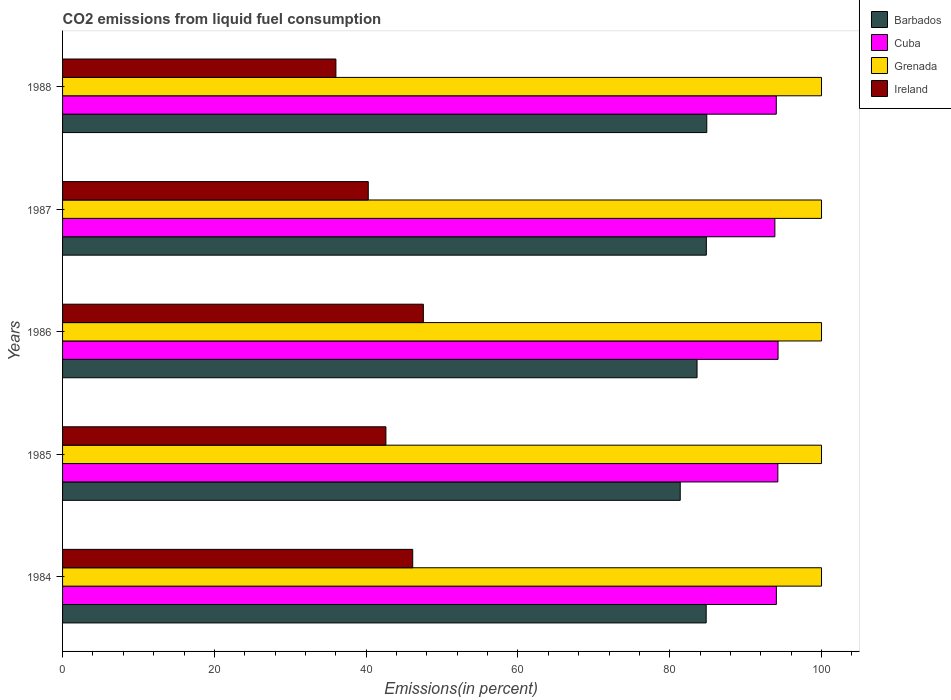How many groups of bars are there?
Offer a very short reply. 5. Are the number of bars per tick equal to the number of legend labels?
Provide a short and direct response. Yes. Are the number of bars on each tick of the Y-axis equal?
Offer a terse response. Yes. How many bars are there on the 4th tick from the top?
Offer a very short reply. 4. How many bars are there on the 4th tick from the bottom?
Offer a terse response. 4. What is the label of the 1st group of bars from the top?
Ensure brevity in your answer.  1988. In how many cases, is the number of bars for a given year not equal to the number of legend labels?
Give a very brief answer. 0. What is the total CO2 emitted in Cuba in 1985?
Provide a short and direct response. 94.25. Across all years, what is the maximum total CO2 emitted in Grenada?
Offer a terse response. 100. Across all years, what is the minimum total CO2 emitted in Grenada?
Your response must be concise. 100. In which year was the total CO2 emitted in Cuba minimum?
Your response must be concise. 1987. What is the total total CO2 emitted in Ireland in the graph?
Provide a short and direct response. 212.57. What is the difference between the total CO2 emitted in Cuba in 1984 and that in 1987?
Your answer should be very brief. 0.2. What is the difference between the total CO2 emitted in Cuba in 1985 and the total CO2 emitted in Ireland in 1986?
Keep it short and to the point. 46.71. What is the average total CO2 emitted in Barbados per year?
Make the answer very short. 83.9. In the year 1988, what is the difference between the total CO2 emitted in Barbados and total CO2 emitted in Ireland?
Your response must be concise. 48.87. What is the ratio of the total CO2 emitted in Barbados in 1986 to that in 1988?
Give a very brief answer. 0.98. Is the total CO2 emitted in Grenada in 1984 less than that in 1988?
Ensure brevity in your answer.  No. What is the difference between the highest and the second highest total CO2 emitted in Ireland?
Your response must be concise. 1.4. What is the difference between the highest and the lowest total CO2 emitted in Grenada?
Make the answer very short. 0. In how many years, is the total CO2 emitted in Grenada greater than the average total CO2 emitted in Grenada taken over all years?
Offer a very short reply. 0. What does the 3rd bar from the top in 1984 represents?
Keep it short and to the point. Cuba. What does the 2nd bar from the bottom in 1985 represents?
Your answer should be compact. Cuba. Is it the case that in every year, the sum of the total CO2 emitted in Grenada and total CO2 emitted in Cuba is greater than the total CO2 emitted in Ireland?
Offer a terse response. Yes. How many bars are there?
Offer a terse response. 20. Are all the bars in the graph horizontal?
Offer a terse response. Yes. How many years are there in the graph?
Make the answer very short. 5. What is the difference between two consecutive major ticks on the X-axis?
Your answer should be very brief. 20. Does the graph contain any zero values?
Ensure brevity in your answer.  No. Does the graph contain grids?
Give a very brief answer. No. Where does the legend appear in the graph?
Keep it short and to the point. Top right. What is the title of the graph?
Your response must be concise. CO2 emissions from liquid fuel consumption. Does "Caribbean small states" appear as one of the legend labels in the graph?
Provide a succinct answer. No. What is the label or title of the X-axis?
Provide a succinct answer. Emissions(in percent). What is the label or title of the Y-axis?
Make the answer very short. Years. What is the Emissions(in percent) of Barbados in 1984?
Your answer should be very brief. 84.8. What is the Emissions(in percent) of Cuba in 1984?
Keep it short and to the point. 94.05. What is the Emissions(in percent) in Ireland in 1984?
Provide a short and direct response. 46.14. What is the Emissions(in percent) of Barbados in 1985?
Provide a short and direct response. 81.39. What is the Emissions(in percent) of Cuba in 1985?
Keep it short and to the point. 94.25. What is the Emissions(in percent) of Grenada in 1985?
Provide a succinct answer. 100. What is the Emissions(in percent) in Ireland in 1985?
Keep it short and to the point. 42.6. What is the Emissions(in percent) of Barbados in 1986?
Make the answer very short. 83.6. What is the Emissions(in percent) in Cuba in 1986?
Keep it short and to the point. 94.28. What is the Emissions(in percent) in Ireland in 1986?
Give a very brief answer. 47.54. What is the Emissions(in percent) in Barbados in 1987?
Ensure brevity in your answer.  84.82. What is the Emissions(in percent) of Cuba in 1987?
Make the answer very short. 93.85. What is the Emissions(in percent) in Ireland in 1987?
Your answer should be compact. 40.28. What is the Emissions(in percent) in Barbados in 1988?
Keep it short and to the point. 84.88. What is the Emissions(in percent) of Cuba in 1988?
Provide a succinct answer. 94.04. What is the Emissions(in percent) in Ireland in 1988?
Offer a very short reply. 36.02. Across all years, what is the maximum Emissions(in percent) in Barbados?
Your response must be concise. 84.88. Across all years, what is the maximum Emissions(in percent) in Cuba?
Your response must be concise. 94.28. Across all years, what is the maximum Emissions(in percent) of Grenada?
Provide a succinct answer. 100. Across all years, what is the maximum Emissions(in percent) in Ireland?
Give a very brief answer. 47.54. Across all years, what is the minimum Emissions(in percent) in Barbados?
Offer a terse response. 81.39. Across all years, what is the minimum Emissions(in percent) in Cuba?
Provide a short and direct response. 93.85. Across all years, what is the minimum Emissions(in percent) in Ireland?
Provide a short and direct response. 36.02. What is the total Emissions(in percent) in Barbados in the graph?
Provide a succinct answer. 419.5. What is the total Emissions(in percent) in Cuba in the graph?
Your response must be concise. 470.47. What is the total Emissions(in percent) in Grenada in the graph?
Provide a succinct answer. 500. What is the total Emissions(in percent) of Ireland in the graph?
Your answer should be very brief. 212.57. What is the difference between the Emissions(in percent) in Barbados in 1984 and that in 1985?
Provide a short and direct response. 3.42. What is the difference between the Emissions(in percent) of Cuba in 1984 and that in 1985?
Your response must be concise. -0.2. What is the difference between the Emissions(in percent) in Ireland in 1984 and that in 1985?
Your response must be concise. 3.53. What is the difference between the Emissions(in percent) in Barbados in 1984 and that in 1986?
Provide a succinct answer. 1.2. What is the difference between the Emissions(in percent) in Cuba in 1984 and that in 1986?
Offer a very short reply. -0.23. What is the difference between the Emissions(in percent) in Grenada in 1984 and that in 1986?
Keep it short and to the point. 0. What is the difference between the Emissions(in percent) in Ireland in 1984 and that in 1986?
Your response must be concise. -1.4. What is the difference between the Emissions(in percent) in Barbados in 1984 and that in 1987?
Your answer should be compact. -0.02. What is the difference between the Emissions(in percent) in Cuba in 1984 and that in 1987?
Your answer should be compact. 0.2. What is the difference between the Emissions(in percent) of Grenada in 1984 and that in 1987?
Offer a terse response. 0. What is the difference between the Emissions(in percent) in Ireland in 1984 and that in 1987?
Keep it short and to the point. 5.86. What is the difference between the Emissions(in percent) in Barbados in 1984 and that in 1988?
Your answer should be compact. -0.08. What is the difference between the Emissions(in percent) of Cuba in 1984 and that in 1988?
Your answer should be compact. 0.01. What is the difference between the Emissions(in percent) of Grenada in 1984 and that in 1988?
Provide a succinct answer. 0. What is the difference between the Emissions(in percent) of Ireland in 1984 and that in 1988?
Make the answer very short. 10.12. What is the difference between the Emissions(in percent) of Barbados in 1985 and that in 1986?
Offer a very short reply. -2.21. What is the difference between the Emissions(in percent) of Cuba in 1985 and that in 1986?
Offer a terse response. -0.03. What is the difference between the Emissions(in percent) in Grenada in 1985 and that in 1986?
Keep it short and to the point. 0. What is the difference between the Emissions(in percent) of Ireland in 1985 and that in 1986?
Your response must be concise. -4.93. What is the difference between the Emissions(in percent) in Barbados in 1985 and that in 1987?
Ensure brevity in your answer.  -3.44. What is the difference between the Emissions(in percent) in Cuba in 1985 and that in 1987?
Keep it short and to the point. 0.39. What is the difference between the Emissions(in percent) of Grenada in 1985 and that in 1987?
Ensure brevity in your answer.  0. What is the difference between the Emissions(in percent) of Ireland in 1985 and that in 1987?
Your answer should be very brief. 2.33. What is the difference between the Emissions(in percent) of Barbados in 1985 and that in 1988?
Your response must be concise. -3.5. What is the difference between the Emissions(in percent) of Cuba in 1985 and that in 1988?
Give a very brief answer. 0.21. What is the difference between the Emissions(in percent) in Ireland in 1985 and that in 1988?
Your answer should be compact. 6.59. What is the difference between the Emissions(in percent) in Barbados in 1986 and that in 1987?
Your answer should be very brief. -1.22. What is the difference between the Emissions(in percent) of Cuba in 1986 and that in 1987?
Ensure brevity in your answer.  0.42. What is the difference between the Emissions(in percent) of Ireland in 1986 and that in 1987?
Your response must be concise. 7.26. What is the difference between the Emissions(in percent) in Barbados in 1986 and that in 1988?
Keep it short and to the point. -1.28. What is the difference between the Emissions(in percent) in Cuba in 1986 and that in 1988?
Offer a very short reply. 0.23. What is the difference between the Emissions(in percent) of Grenada in 1986 and that in 1988?
Offer a terse response. 0. What is the difference between the Emissions(in percent) in Ireland in 1986 and that in 1988?
Your answer should be compact. 11.52. What is the difference between the Emissions(in percent) of Barbados in 1987 and that in 1988?
Your response must be concise. -0.06. What is the difference between the Emissions(in percent) in Cuba in 1987 and that in 1988?
Provide a short and direct response. -0.19. What is the difference between the Emissions(in percent) in Grenada in 1987 and that in 1988?
Offer a very short reply. 0. What is the difference between the Emissions(in percent) in Ireland in 1987 and that in 1988?
Your answer should be very brief. 4.26. What is the difference between the Emissions(in percent) in Barbados in 1984 and the Emissions(in percent) in Cuba in 1985?
Provide a succinct answer. -9.44. What is the difference between the Emissions(in percent) in Barbados in 1984 and the Emissions(in percent) in Grenada in 1985?
Provide a succinct answer. -15.2. What is the difference between the Emissions(in percent) of Barbados in 1984 and the Emissions(in percent) of Ireland in 1985?
Give a very brief answer. 42.2. What is the difference between the Emissions(in percent) in Cuba in 1984 and the Emissions(in percent) in Grenada in 1985?
Keep it short and to the point. -5.95. What is the difference between the Emissions(in percent) in Cuba in 1984 and the Emissions(in percent) in Ireland in 1985?
Provide a short and direct response. 51.45. What is the difference between the Emissions(in percent) of Grenada in 1984 and the Emissions(in percent) of Ireland in 1985?
Provide a short and direct response. 57.4. What is the difference between the Emissions(in percent) in Barbados in 1984 and the Emissions(in percent) in Cuba in 1986?
Give a very brief answer. -9.47. What is the difference between the Emissions(in percent) in Barbados in 1984 and the Emissions(in percent) in Grenada in 1986?
Your answer should be very brief. -15.2. What is the difference between the Emissions(in percent) of Barbados in 1984 and the Emissions(in percent) of Ireland in 1986?
Offer a very short reply. 37.27. What is the difference between the Emissions(in percent) of Cuba in 1984 and the Emissions(in percent) of Grenada in 1986?
Your answer should be very brief. -5.95. What is the difference between the Emissions(in percent) of Cuba in 1984 and the Emissions(in percent) of Ireland in 1986?
Give a very brief answer. 46.51. What is the difference between the Emissions(in percent) of Grenada in 1984 and the Emissions(in percent) of Ireland in 1986?
Provide a short and direct response. 52.46. What is the difference between the Emissions(in percent) in Barbados in 1984 and the Emissions(in percent) in Cuba in 1987?
Your answer should be compact. -9.05. What is the difference between the Emissions(in percent) in Barbados in 1984 and the Emissions(in percent) in Grenada in 1987?
Provide a short and direct response. -15.2. What is the difference between the Emissions(in percent) in Barbados in 1984 and the Emissions(in percent) in Ireland in 1987?
Provide a short and direct response. 44.52. What is the difference between the Emissions(in percent) in Cuba in 1984 and the Emissions(in percent) in Grenada in 1987?
Your answer should be very brief. -5.95. What is the difference between the Emissions(in percent) of Cuba in 1984 and the Emissions(in percent) of Ireland in 1987?
Provide a succinct answer. 53.77. What is the difference between the Emissions(in percent) of Grenada in 1984 and the Emissions(in percent) of Ireland in 1987?
Provide a short and direct response. 59.72. What is the difference between the Emissions(in percent) of Barbados in 1984 and the Emissions(in percent) of Cuba in 1988?
Offer a terse response. -9.24. What is the difference between the Emissions(in percent) in Barbados in 1984 and the Emissions(in percent) in Grenada in 1988?
Provide a succinct answer. -15.2. What is the difference between the Emissions(in percent) of Barbados in 1984 and the Emissions(in percent) of Ireland in 1988?
Offer a very short reply. 48.79. What is the difference between the Emissions(in percent) of Cuba in 1984 and the Emissions(in percent) of Grenada in 1988?
Provide a short and direct response. -5.95. What is the difference between the Emissions(in percent) in Cuba in 1984 and the Emissions(in percent) in Ireland in 1988?
Offer a terse response. 58.03. What is the difference between the Emissions(in percent) of Grenada in 1984 and the Emissions(in percent) of Ireland in 1988?
Your answer should be compact. 63.98. What is the difference between the Emissions(in percent) in Barbados in 1985 and the Emissions(in percent) in Cuba in 1986?
Your response must be concise. -12.89. What is the difference between the Emissions(in percent) of Barbados in 1985 and the Emissions(in percent) of Grenada in 1986?
Ensure brevity in your answer.  -18.61. What is the difference between the Emissions(in percent) in Barbados in 1985 and the Emissions(in percent) in Ireland in 1986?
Provide a succinct answer. 33.85. What is the difference between the Emissions(in percent) in Cuba in 1985 and the Emissions(in percent) in Grenada in 1986?
Offer a very short reply. -5.75. What is the difference between the Emissions(in percent) of Cuba in 1985 and the Emissions(in percent) of Ireland in 1986?
Your answer should be compact. 46.71. What is the difference between the Emissions(in percent) in Grenada in 1985 and the Emissions(in percent) in Ireland in 1986?
Offer a terse response. 52.46. What is the difference between the Emissions(in percent) in Barbados in 1985 and the Emissions(in percent) in Cuba in 1987?
Your answer should be compact. -12.47. What is the difference between the Emissions(in percent) of Barbados in 1985 and the Emissions(in percent) of Grenada in 1987?
Provide a short and direct response. -18.61. What is the difference between the Emissions(in percent) in Barbados in 1985 and the Emissions(in percent) in Ireland in 1987?
Ensure brevity in your answer.  41.11. What is the difference between the Emissions(in percent) in Cuba in 1985 and the Emissions(in percent) in Grenada in 1987?
Ensure brevity in your answer.  -5.75. What is the difference between the Emissions(in percent) of Cuba in 1985 and the Emissions(in percent) of Ireland in 1987?
Your response must be concise. 53.97. What is the difference between the Emissions(in percent) in Grenada in 1985 and the Emissions(in percent) in Ireland in 1987?
Keep it short and to the point. 59.72. What is the difference between the Emissions(in percent) in Barbados in 1985 and the Emissions(in percent) in Cuba in 1988?
Give a very brief answer. -12.66. What is the difference between the Emissions(in percent) in Barbados in 1985 and the Emissions(in percent) in Grenada in 1988?
Offer a terse response. -18.61. What is the difference between the Emissions(in percent) of Barbados in 1985 and the Emissions(in percent) of Ireland in 1988?
Keep it short and to the point. 45.37. What is the difference between the Emissions(in percent) of Cuba in 1985 and the Emissions(in percent) of Grenada in 1988?
Offer a very short reply. -5.75. What is the difference between the Emissions(in percent) of Cuba in 1985 and the Emissions(in percent) of Ireland in 1988?
Keep it short and to the point. 58.23. What is the difference between the Emissions(in percent) of Grenada in 1985 and the Emissions(in percent) of Ireland in 1988?
Offer a terse response. 63.98. What is the difference between the Emissions(in percent) of Barbados in 1986 and the Emissions(in percent) of Cuba in 1987?
Your response must be concise. -10.25. What is the difference between the Emissions(in percent) in Barbados in 1986 and the Emissions(in percent) in Grenada in 1987?
Your answer should be compact. -16.4. What is the difference between the Emissions(in percent) in Barbados in 1986 and the Emissions(in percent) in Ireland in 1987?
Give a very brief answer. 43.32. What is the difference between the Emissions(in percent) in Cuba in 1986 and the Emissions(in percent) in Grenada in 1987?
Your answer should be very brief. -5.72. What is the difference between the Emissions(in percent) in Cuba in 1986 and the Emissions(in percent) in Ireland in 1987?
Your answer should be compact. 54. What is the difference between the Emissions(in percent) of Grenada in 1986 and the Emissions(in percent) of Ireland in 1987?
Make the answer very short. 59.72. What is the difference between the Emissions(in percent) in Barbados in 1986 and the Emissions(in percent) in Cuba in 1988?
Your response must be concise. -10.44. What is the difference between the Emissions(in percent) of Barbados in 1986 and the Emissions(in percent) of Grenada in 1988?
Offer a terse response. -16.4. What is the difference between the Emissions(in percent) of Barbados in 1986 and the Emissions(in percent) of Ireland in 1988?
Ensure brevity in your answer.  47.58. What is the difference between the Emissions(in percent) in Cuba in 1986 and the Emissions(in percent) in Grenada in 1988?
Provide a short and direct response. -5.72. What is the difference between the Emissions(in percent) in Cuba in 1986 and the Emissions(in percent) in Ireland in 1988?
Your response must be concise. 58.26. What is the difference between the Emissions(in percent) in Grenada in 1986 and the Emissions(in percent) in Ireland in 1988?
Ensure brevity in your answer.  63.98. What is the difference between the Emissions(in percent) in Barbados in 1987 and the Emissions(in percent) in Cuba in 1988?
Your response must be concise. -9.22. What is the difference between the Emissions(in percent) in Barbados in 1987 and the Emissions(in percent) in Grenada in 1988?
Offer a terse response. -15.18. What is the difference between the Emissions(in percent) in Barbados in 1987 and the Emissions(in percent) in Ireland in 1988?
Your response must be concise. 48.81. What is the difference between the Emissions(in percent) of Cuba in 1987 and the Emissions(in percent) of Grenada in 1988?
Give a very brief answer. -6.15. What is the difference between the Emissions(in percent) of Cuba in 1987 and the Emissions(in percent) of Ireland in 1988?
Your answer should be very brief. 57.84. What is the difference between the Emissions(in percent) of Grenada in 1987 and the Emissions(in percent) of Ireland in 1988?
Your answer should be compact. 63.98. What is the average Emissions(in percent) of Barbados per year?
Offer a very short reply. 83.9. What is the average Emissions(in percent) in Cuba per year?
Make the answer very short. 94.09. What is the average Emissions(in percent) of Ireland per year?
Your answer should be very brief. 42.51. In the year 1984, what is the difference between the Emissions(in percent) of Barbados and Emissions(in percent) of Cuba?
Your response must be concise. -9.25. In the year 1984, what is the difference between the Emissions(in percent) of Barbados and Emissions(in percent) of Grenada?
Your response must be concise. -15.2. In the year 1984, what is the difference between the Emissions(in percent) of Barbados and Emissions(in percent) of Ireland?
Ensure brevity in your answer.  38.67. In the year 1984, what is the difference between the Emissions(in percent) in Cuba and Emissions(in percent) in Grenada?
Provide a short and direct response. -5.95. In the year 1984, what is the difference between the Emissions(in percent) of Cuba and Emissions(in percent) of Ireland?
Keep it short and to the point. 47.91. In the year 1984, what is the difference between the Emissions(in percent) in Grenada and Emissions(in percent) in Ireland?
Your response must be concise. 53.86. In the year 1985, what is the difference between the Emissions(in percent) of Barbados and Emissions(in percent) of Cuba?
Your answer should be very brief. -12.86. In the year 1985, what is the difference between the Emissions(in percent) in Barbados and Emissions(in percent) in Grenada?
Make the answer very short. -18.61. In the year 1985, what is the difference between the Emissions(in percent) in Barbados and Emissions(in percent) in Ireland?
Make the answer very short. 38.78. In the year 1985, what is the difference between the Emissions(in percent) in Cuba and Emissions(in percent) in Grenada?
Make the answer very short. -5.75. In the year 1985, what is the difference between the Emissions(in percent) of Cuba and Emissions(in percent) of Ireland?
Offer a very short reply. 51.64. In the year 1985, what is the difference between the Emissions(in percent) in Grenada and Emissions(in percent) in Ireland?
Make the answer very short. 57.4. In the year 1986, what is the difference between the Emissions(in percent) of Barbados and Emissions(in percent) of Cuba?
Provide a succinct answer. -10.68. In the year 1986, what is the difference between the Emissions(in percent) in Barbados and Emissions(in percent) in Grenada?
Give a very brief answer. -16.4. In the year 1986, what is the difference between the Emissions(in percent) of Barbados and Emissions(in percent) of Ireland?
Offer a terse response. 36.06. In the year 1986, what is the difference between the Emissions(in percent) of Cuba and Emissions(in percent) of Grenada?
Make the answer very short. -5.72. In the year 1986, what is the difference between the Emissions(in percent) of Cuba and Emissions(in percent) of Ireland?
Keep it short and to the point. 46.74. In the year 1986, what is the difference between the Emissions(in percent) in Grenada and Emissions(in percent) in Ireland?
Offer a terse response. 52.46. In the year 1987, what is the difference between the Emissions(in percent) of Barbados and Emissions(in percent) of Cuba?
Make the answer very short. -9.03. In the year 1987, what is the difference between the Emissions(in percent) of Barbados and Emissions(in percent) of Grenada?
Your answer should be compact. -15.18. In the year 1987, what is the difference between the Emissions(in percent) in Barbados and Emissions(in percent) in Ireland?
Ensure brevity in your answer.  44.55. In the year 1987, what is the difference between the Emissions(in percent) of Cuba and Emissions(in percent) of Grenada?
Offer a very short reply. -6.15. In the year 1987, what is the difference between the Emissions(in percent) in Cuba and Emissions(in percent) in Ireland?
Your answer should be very brief. 53.58. In the year 1987, what is the difference between the Emissions(in percent) of Grenada and Emissions(in percent) of Ireland?
Provide a succinct answer. 59.72. In the year 1988, what is the difference between the Emissions(in percent) of Barbados and Emissions(in percent) of Cuba?
Ensure brevity in your answer.  -9.16. In the year 1988, what is the difference between the Emissions(in percent) in Barbados and Emissions(in percent) in Grenada?
Keep it short and to the point. -15.12. In the year 1988, what is the difference between the Emissions(in percent) of Barbados and Emissions(in percent) of Ireland?
Your response must be concise. 48.87. In the year 1988, what is the difference between the Emissions(in percent) in Cuba and Emissions(in percent) in Grenada?
Your answer should be compact. -5.96. In the year 1988, what is the difference between the Emissions(in percent) of Cuba and Emissions(in percent) of Ireland?
Your response must be concise. 58.03. In the year 1988, what is the difference between the Emissions(in percent) in Grenada and Emissions(in percent) in Ireland?
Ensure brevity in your answer.  63.98. What is the ratio of the Emissions(in percent) in Barbados in 1984 to that in 1985?
Your answer should be compact. 1.04. What is the ratio of the Emissions(in percent) in Grenada in 1984 to that in 1985?
Keep it short and to the point. 1. What is the ratio of the Emissions(in percent) of Ireland in 1984 to that in 1985?
Your answer should be very brief. 1.08. What is the ratio of the Emissions(in percent) of Barbados in 1984 to that in 1986?
Give a very brief answer. 1.01. What is the ratio of the Emissions(in percent) of Ireland in 1984 to that in 1986?
Provide a succinct answer. 0.97. What is the ratio of the Emissions(in percent) of Barbados in 1984 to that in 1987?
Provide a succinct answer. 1. What is the ratio of the Emissions(in percent) in Cuba in 1984 to that in 1987?
Your response must be concise. 1. What is the ratio of the Emissions(in percent) in Grenada in 1984 to that in 1987?
Ensure brevity in your answer.  1. What is the ratio of the Emissions(in percent) in Ireland in 1984 to that in 1987?
Your response must be concise. 1.15. What is the ratio of the Emissions(in percent) in Barbados in 1984 to that in 1988?
Offer a very short reply. 1. What is the ratio of the Emissions(in percent) of Cuba in 1984 to that in 1988?
Ensure brevity in your answer.  1. What is the ratio of the Emissions(in percent) of Ireland in 1984 to that in 1988?
Your answer should be very brief. 1.28. What is the ratio of the Emissions(in percent) of Barbados in 1985 to that in 1986?
Offer a terse response. 0.97. What is the ratio of the Emissions(in percent) in Grenada in 1985 to that in 1986?
Your answer should be compact. 1. What is the ratio of the Emissions(in percent) in Ireland in 1985 to that in 1986?
Your response must be concise. 0.9. What is the ratio of the Emissions(in percent) of Barbados in 1985 to that in 1987?
Give a very brief answer. 0.96. What is the ratio of the Emissions(in percent) in Cuba in 1985 to that in 1987?
Ensure brevity in your answer.  1. What is the ratio of the Emissions(in percent) of Grenada in 1985 to that in 1987?
Your answer should be very brief. 1. What is the ratio of the Emissions(in percent) in Ireland in 1985 to that in 1987?
Your answer should be compact. 1.06. What is the ratio of the Emissions(in percent) of Barbados in 1985 to that in 1988?
Provide a short and direct response. 0.96. What is the ratio of the Emissions(in percent) in Ireland in 1985 to that in 1988?
Provide a succinct answer. 1.18. What is the ratio of the Emissions(in percent) of Barbados in 1986 to that in 1987?
Give a very brief answer. 0.99. What is the ratio of the Emissions(in percent) of Cuba in 1986 to that in 1987?
Keep it short and to the point. 1. What is the ratio of the Emissions(in percent) in Ireland in 1986 to that in 1987?
Make the answer very short. 1.18. What is the ratio of the Emissions(in percent) in Barbados in 1986 to that in 1988?
Provide a succinct answer. 0.98. What is the ratio of the Emissions(in percent) of Cuba in 1986 to that in 1988?
Make the answer very short. 1. What is the ratio of the Emissions(in percent) of Grenada in 1986 to that in 1988?
Your response must be concise. 1. What is the ratio of the Emissions(in percent) in Ireland in 1986 to that in 1988?
Ensure brevity in your answer.  1.32. What is the ratio of the Emissions(in percent) of Barbados in 1987 to that in 1988?
Keep it short and to the point. 1. What is the ratio of the Emissions(in percent) of Cuba in 1987 to that in 1988?
Ensure brevity in your answer.  1. What is the ratio of the Emissions(in percent) in Grenada in 1987 to that in 1988?
Ensure brevity in your answer.  1. What is the ratio of the Emissions(in percent) in Ireland in 1987 to that in 1988?
Your answer should be compact. 1.12. What is the difference between the highest and the second highest Emissions(in percent) of Barbados?
Your response must be concise. 0.06. What is the difference between the highest and the second highest Emissions(in percent) in Cuba?
Keep it short and to the point. 0.03. What is the difference between the highest and the second highest Emissions(in percent) of Ireland?
Ensure brevity in your answer.  1.4. What is the difference between the highest and the lowest Emissions(in percent) of Barbados?
Provide a short and direct response. 3.5. What is the difference between the highest and the lowest Emissions(in percent) of Cuba?
Your answer should be very brief. 0.42. What is the difference between the highest and the lowest Emissions(in percent) in Ireland?
Give a very brief answer. 11.52. 